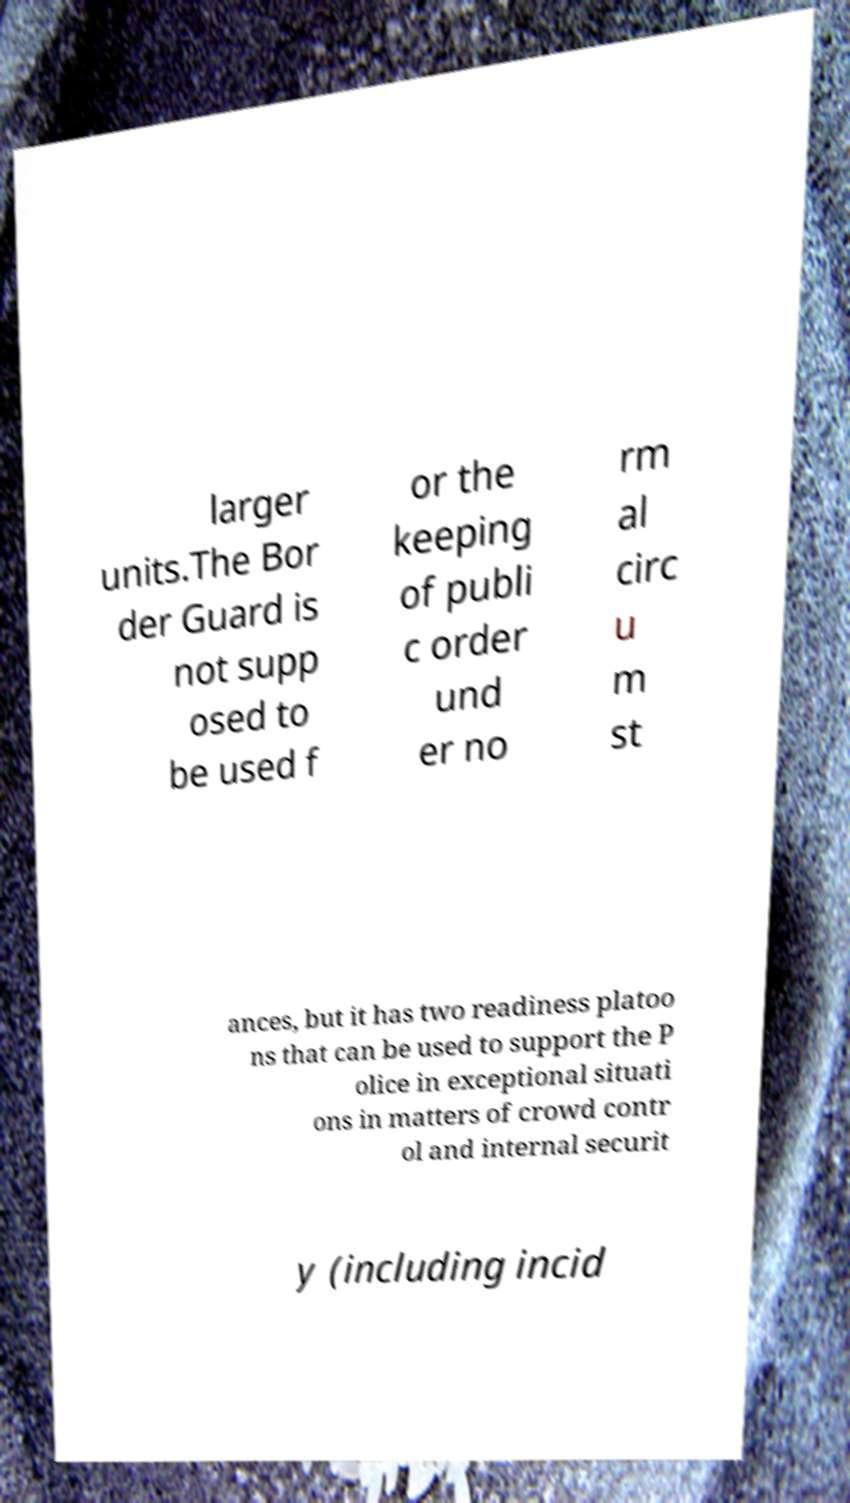Can you read and provide the text displayed in the image?This photo seems to have some interesting text. Can you extract and type it out for me? larger units.The Bor der Guard is not supp osed to be used f or the keeping of publi c order und er no rm al circ u m st ances, but it has two readiness platoo ns that can be used to support the P olice in exceptional situati ons in matters of crowd contr ol and internal securit y (including incid 